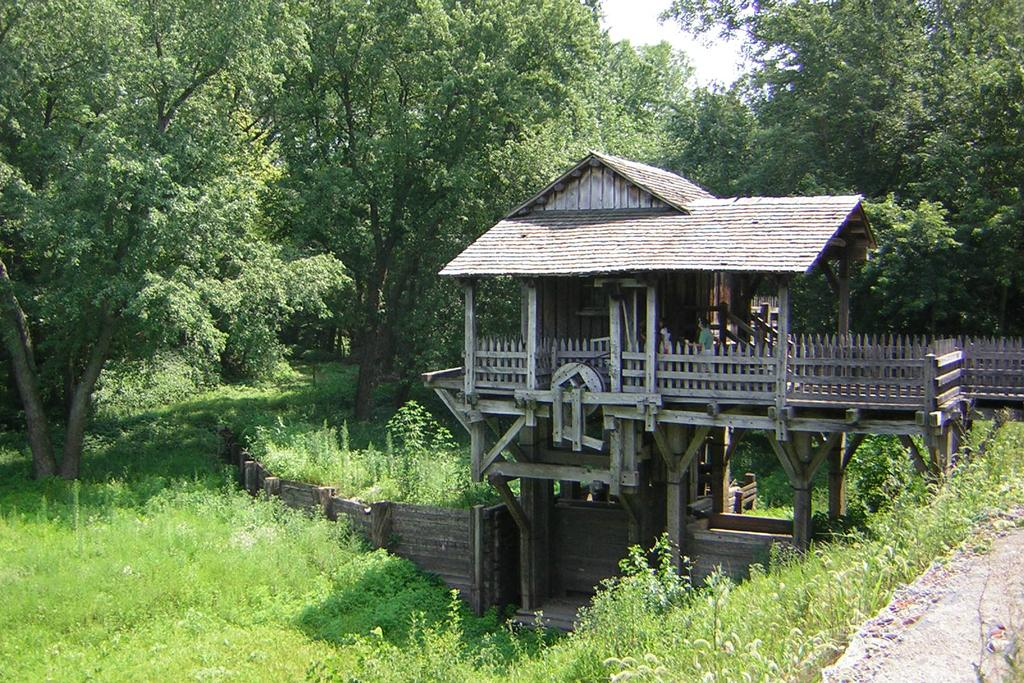What type of house is in the center of the image? There is a wooden house in the center of the image. What can be seen around the house in the image? There is greenery around the area of the image. What type of butter is being used to paint the house in the image? There is no butter present in the image, and the house is not being painted. 